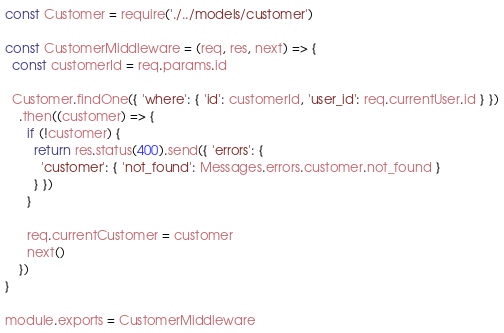<code> <loc_0><loc_0><loc_500><loc_500><_JavaScript_>const Customer = require('./../models/customer')

const CustomerMiddleware = (req, res, next) => {
  const customerId = req.params.id

  Customer.findOne({ 'where': { 'id': customerId, 'user_id': req.currentUser.id } })
    .then((customer) => {
      if (!customer) {
        return res.status(400).send({ 'errors': {
          'customer': { 'not_found': Messages.errors.customer.not_found }
        } })
      }

      req.currentCustomer = customer
      next()
    })
}

module.exports = CustomerMiddleware
</code> 